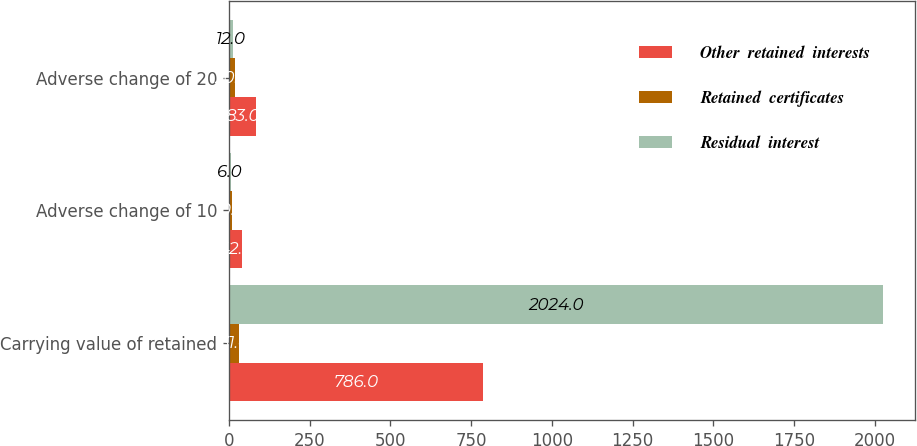Convert chart to OTSL. <chart><loc_0><loc_0><loc_500><loc_500><stacked_bar_chart><ecel><fcel>Carrying value of retained<fcel>Adverse change of 10<fcel>Adverse change of 20<nl><fcel>Other  retained  interests<fcel>786<fcel>42<fcel>83<nl><fcel>Retained  certificates<fcel>31<fcel>10<fcel>20<nl><fcel>Residual  interest<fcel>2024<fcel>6<fcel>12<nl></chart> 